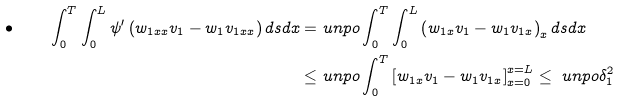Convert formula to latex. <formula><loc_0><loc_0><loc_500><loc_500>\bullet \quad \int _ { 0 } ^ { T } \int _ { 0 } ^ { L } \psi ^ { \prime } \left ( w _ { 1 x x } v _ { 1 } - w _ { 1 } v _ { 1 x x } \right ) d s d x = & \ u n p o \int _ { 0 } ^ { T } \int _ { 0 } ^ { L } \left ( w _ { 1 x } v _ { 1 } - w _ { 1 } v _ { 1 x } \right ) _ { x } d s d x \\ \leq & \ u n p o \int _ { 0 } ^ { T } \left [ w _ { 1 x } v _ { 1 } - w _ { 1 } v _ { 1 x } \right ] ^ { x = L } _ { x = 0 } \leq \ u n p o \delta _ { 1 } ^ { 2 } \\</formula> 